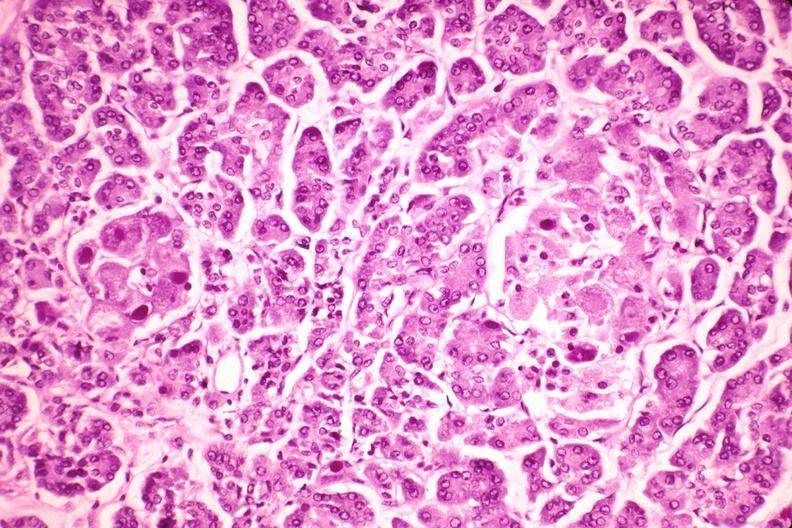what does this image show?
Answer the question using a single word or phrase. Pancreas 